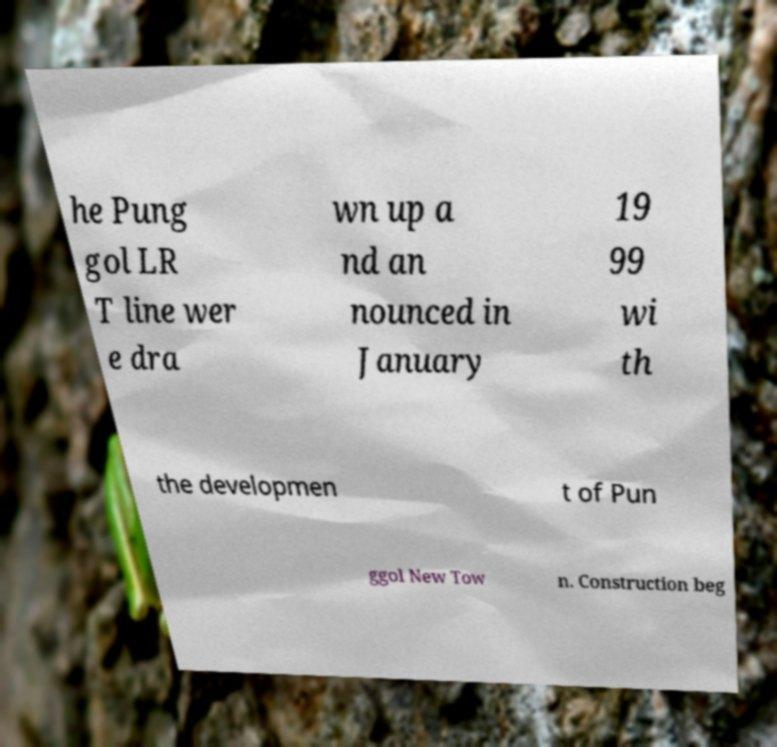There's text embedded in this image that I need extracted. Can you transcribe it verbatim? he Pung gol LR T line wer e dra wn up a nd an nounced in January 19 99 wi th the developmen t of Pun ggol New Tow n. Construction beg 